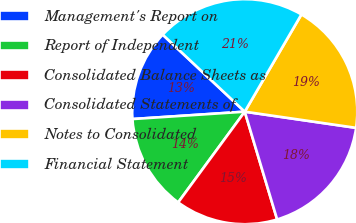Convert chart. <chart><loc_0><loc_0><loc_500><loc_500><pie_chart><fcel>Management's Report on<fcel>Report of Independent<fcel>Consolidated Balance Sheets as<fcel>Consolidated Statements of<fcel>Notes to Consolidated<fcel>Financial Statement<nl><fcel>13.04%<fcel>13.88%<fcel>14.72%<fcel>18.06%<fcel>18.9%<fcel>21.4%<nl></chart> 